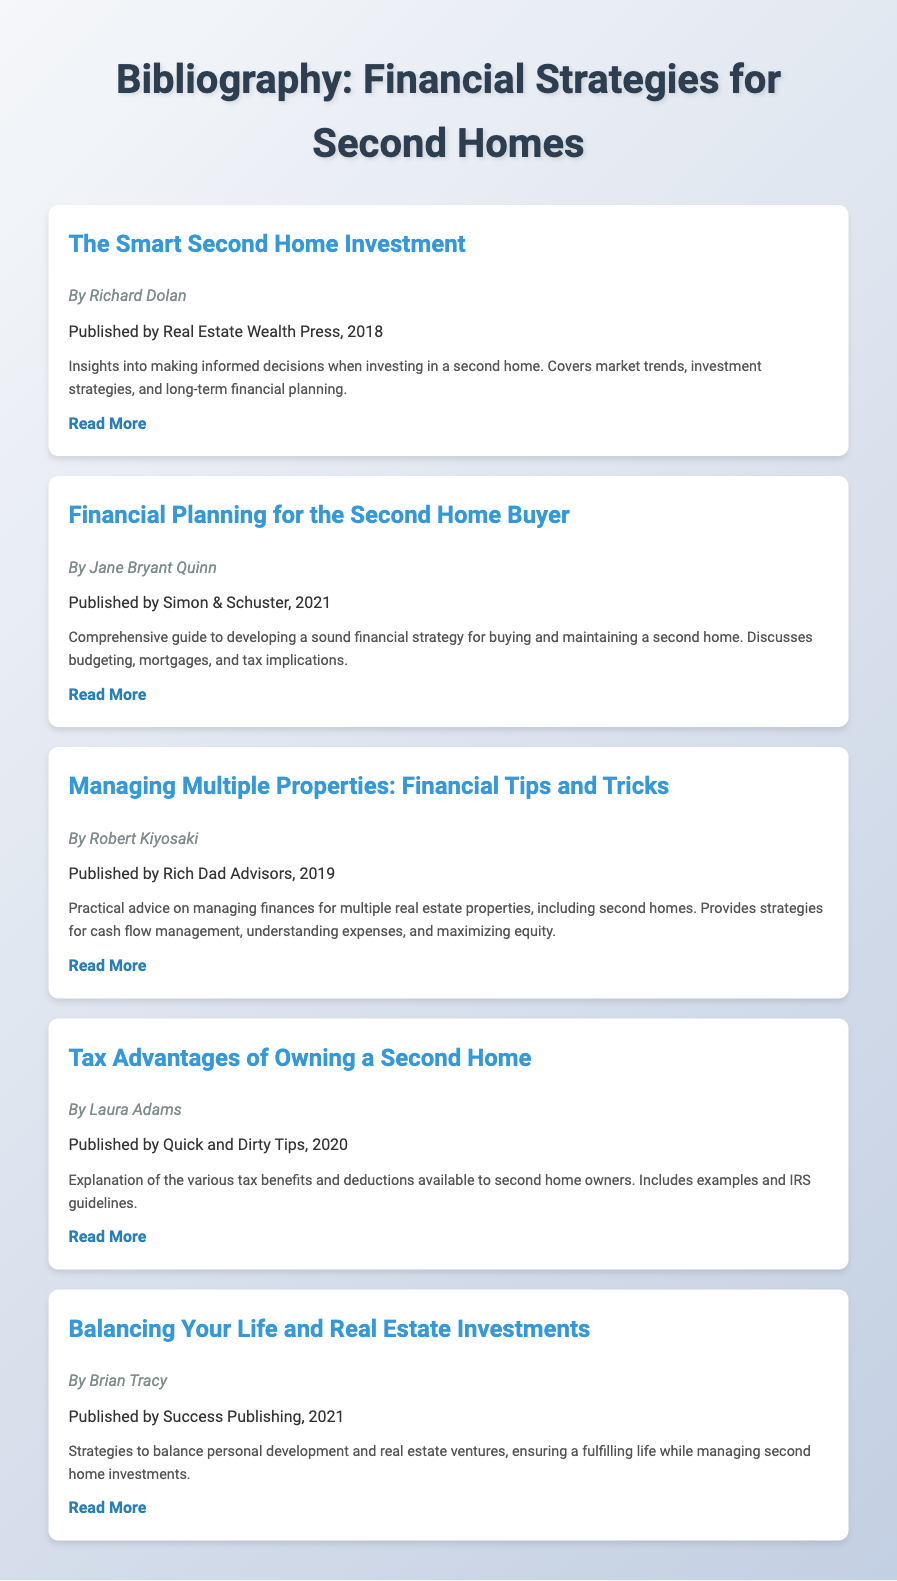What is the title of the first item in the bibliography? The title of the first item in the bibliography is "The Smart Second Home Investment".
Answer: The Smart Second Home Investment Who is the author of the book published in 2021? The book published in 2021 is "Financial Planning for the Second Home Buyer" by Jane Bryant Quinn.
Answer: Jane Bryant Quinn What publishing company released the book by Richard Dolan? The book by Richard Dolan is published by Real Estate Wealth Press.
Answer: Real Estate Wealth Press What year was "Tax Advantages of Owning a Second Home" published? "Tax Advantages of Owning a Second Home" was published in the year 2020.
Answer: 2020 Which author provided strategies to balance personal development and real estate ventures? The author who provided those strategies is Brian Tracy.
Answer: Brian Tracy Name one financial strategy covered in Robert Kiyosaki's book. One financial strategy covered is cash flow management.
Answer: Cash flow management What is the main focus of Laura Adams's book? The main focus of Laura Adams's book is on tax benefits and deductions for second home owners.
Answer: Tax benefits and deductions Which item discusses long-term financial planning? The item that discusses long-term financial planning is "The Smart Second Home Investment".
Answer: The Smart Second Home Investment How many books in the bibliography focus on financial planning or management? There are four books focusing on financial planning or management.
Answer: Four 